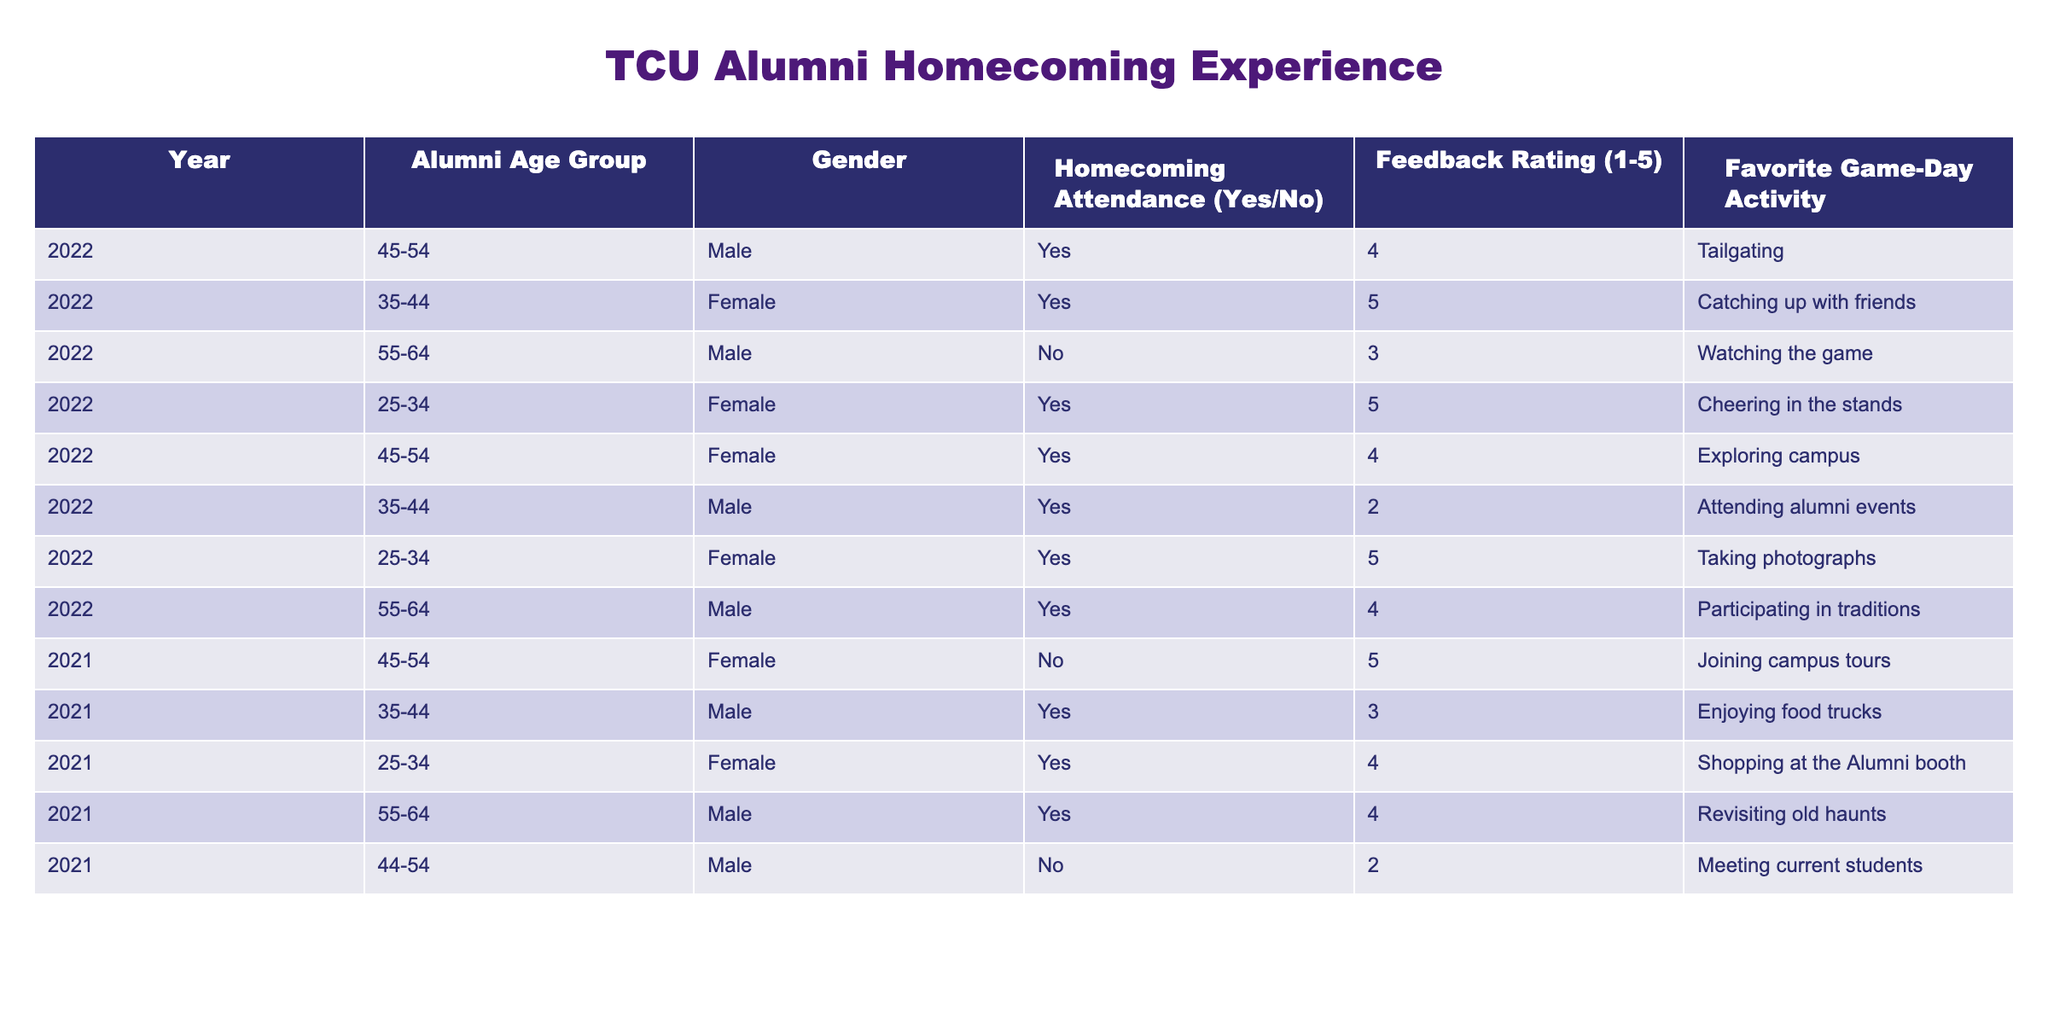What is the feedback rating of alumni aged 35-44 who attended homecoming in 2022? There are two alumni in the 35-44 age group who attended homecoming in 2022. One gave a feedback rating of 5, and the other gave a rating of 2. Since we're interested in the feedback of those who attended, we refer to the one who rated 5.
Answer: 5 What is the favorite game-day activity of alumni aged 55-64 who did not attend homecoming in 2022? There is one alumni in the 55-64 age group who did not attend homecoming in 2022. This alumni's favorite game-day activity is "Watching the game."
Answer: Watching the game What is the percentage of male alumni who attended homecoming in 2022? There are 6 alumni recorded for homecoming in 2022, 4 of whom are male. To find the percentage, we calculate (4/6)*100 = 66.67%.
Answer: 66.67% What is the average feedback rating of alumni who attended homecoming across all age groups in 2021? In 2021, there are three ratings: 3, 4, 4, totaling 11. The average is calculated as 11/3 = 3.67.
Answer: 3.67 Did any female alumni in the 45-54 age group attend homecoming in 2021? Looking at the data, there is one 45-54 age group female alumni listed who did not attend homecoming in 2021, which confirms that there were no females in this age group who attended that year.
Answer: No What are the favorite game-day activities of those alumni aged 25-34 who attended homecoming in 2022? There are two alumni aged 25-34 who attended homecoming in 2022. Their favorite activities are "Cheering in the stands" and "Taking photographs".
Answer: Cheering in the stands, Taking photographs What is the feedback rating of the oldest alumni group (55-64) who attended homecoming? Among the 55-64 age group, there are two alumni who attended. One rated 4, and the other rated 3. The highest feedback rating is 4.
Answer: 4 Is there any alumni feedback rating of 1 reported in the data? After checking the feedback ratings listed, the ratings are between 2 and 5. Therefore, there is no record of an alumni's feedback rating of 1.
Answer: No What is the total number of alumni who attended homecoming in 2021? In 2021, the attendance data lists 4 individuals who attended homecoming. Summing the participants gives a total of 4.
Answer: 4 